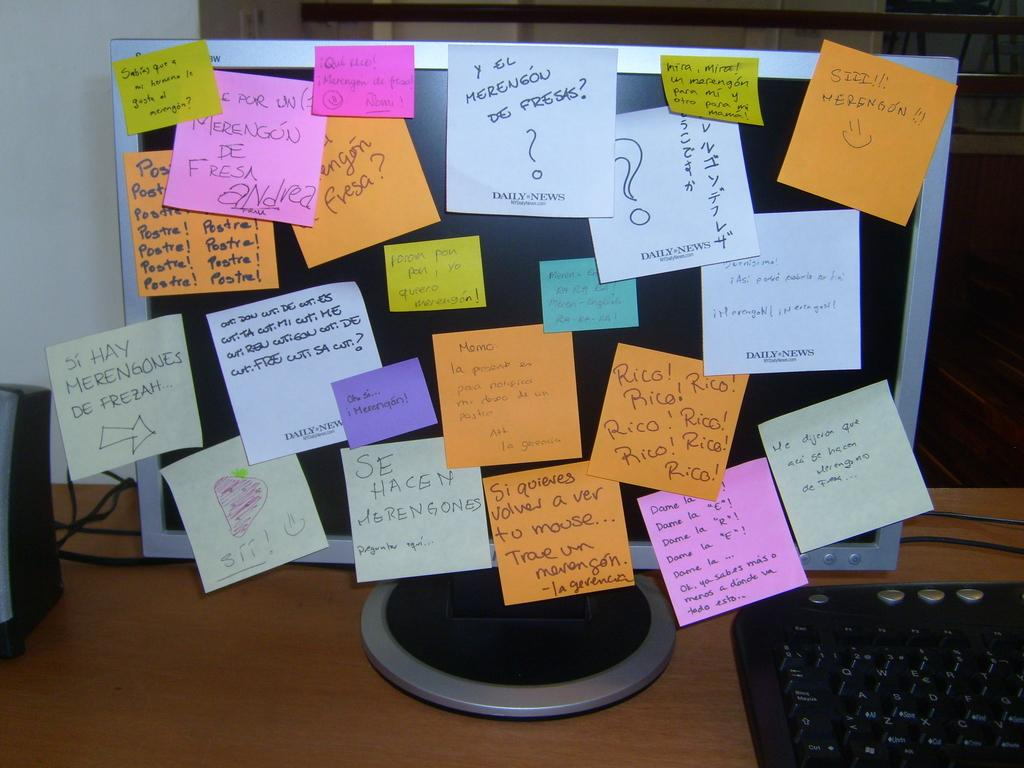Provide a one-sentence caption for the provided image. a computer screen with post it notes all over it with one of them saying 'que rico!. 